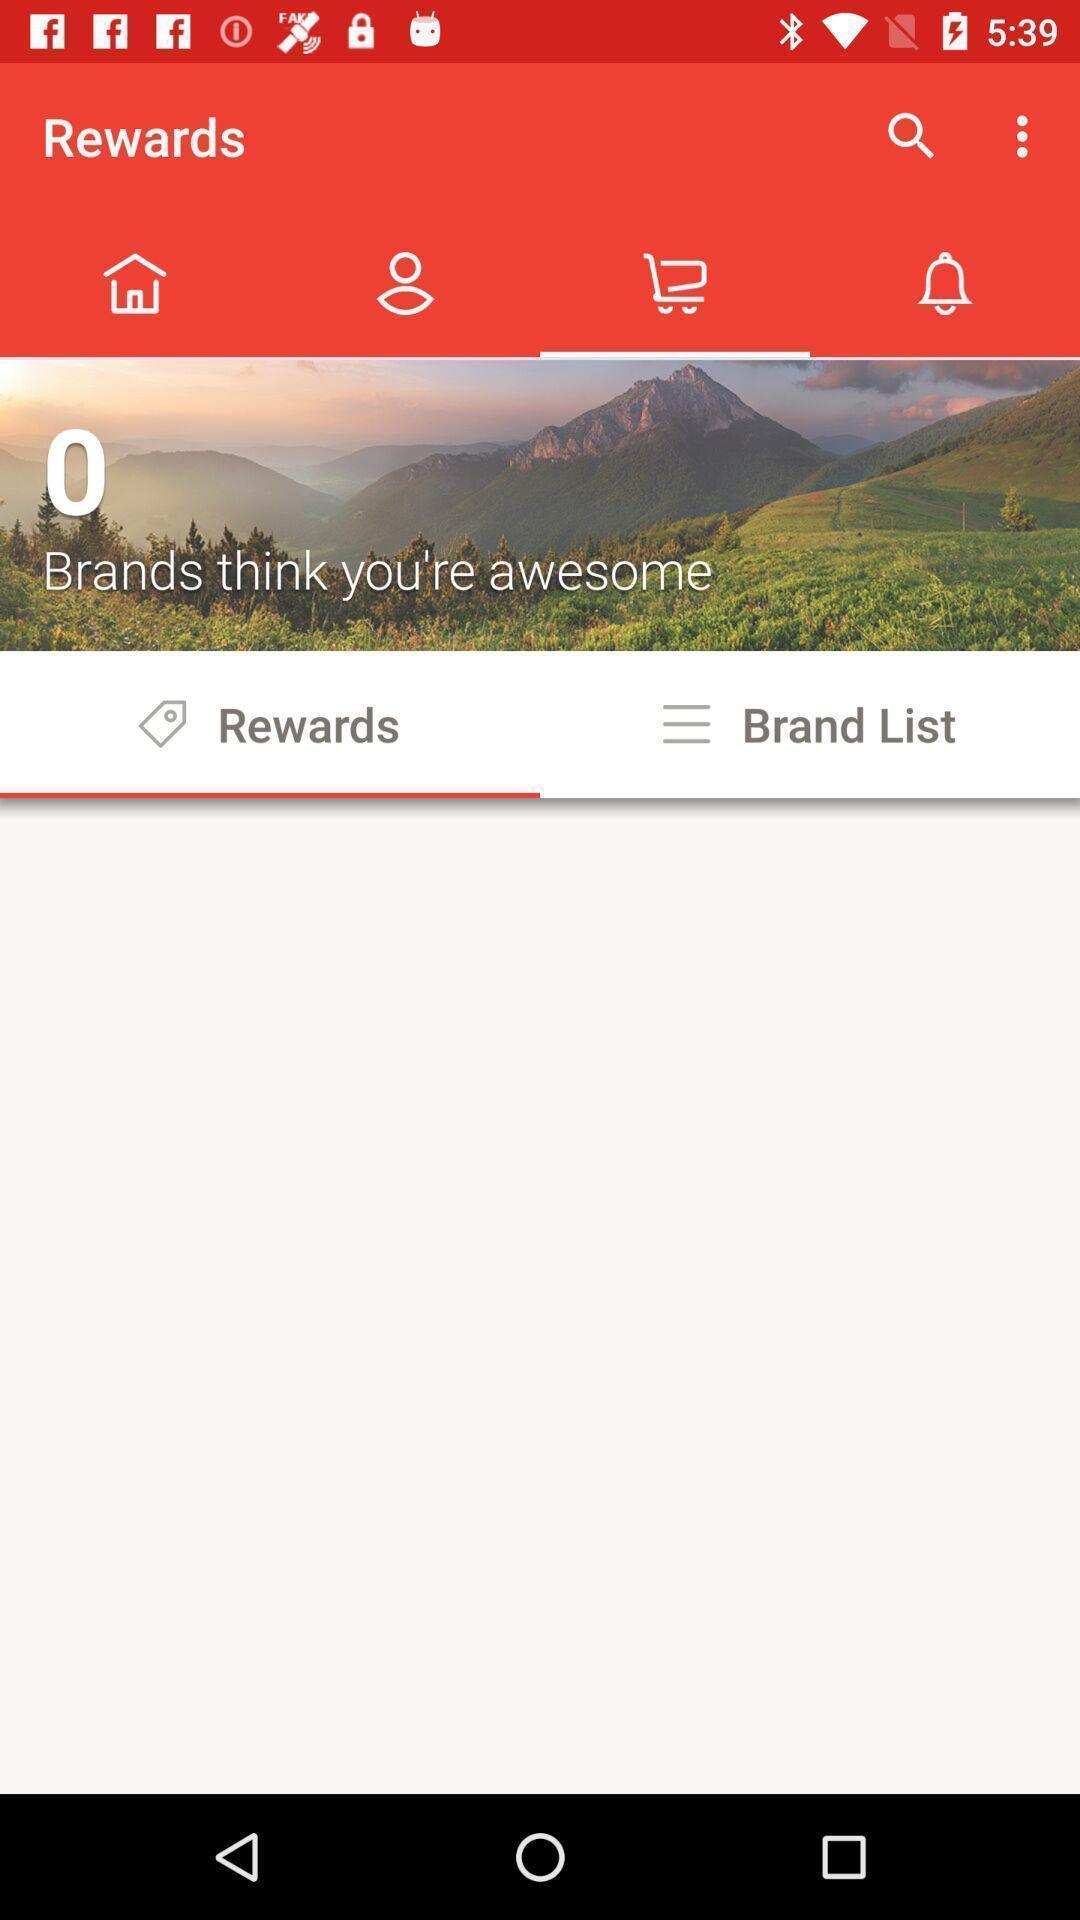Give me a summary of this screen capture. Screen displaying the rewards page. 